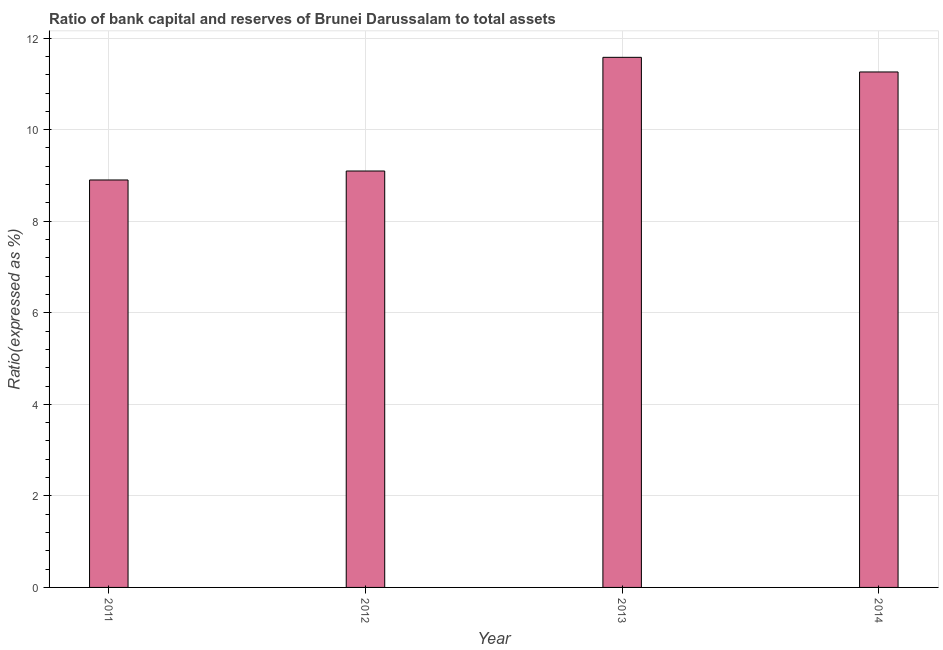Does the graph contain grids?
Ensure brevity in your answer.  Yes. What is the title of the graph?
Provide a short and direct response. Ratio of bank capital and reserves of Brunei Darussalam to total assets. What is the label or title of the X-axis?
Your answer should be very brief. Year. What is the label or title of the Y-axis?
Keep it short and to the point. Ratio(expressed as %). What is the bank capital to assets ratio in 2014?
Your answer should be compact. 11.26. Across all years, what is the maximum bank capital to assets ratio?
Make the answer very short. 11.58. Across all years, what is the minimum bank capital to assets ratio?
Make the answer very short. 8.9. In which year was the bank capital to assets ratio maximum?
Keep it short and to the point. 2013. In which year was the bank capital to assets ratio minimum?
Ensure brevity in your answer.  2011. What is the sum of the bank capital to assets ratio?
Provide a succinct answer. 40.84. What is the difference between the bank capital to assets ratio in 2011 and 2013?
Your answer should be very brief. -2.68. What is the average bank capital to assets ratio per year?
Make the answer very short. 10.21. What is the median bank capital to assets ratio?
Ensure brevity in your answer.  10.18. What is the ratio of the bank capital to assets ratio in 2011 to that in 2014?
Your response must be concise. 0.79. What is the difference between the highest and the second highest bank capital to assets ratio?
Ensure brevity in your answer.  0.32. Is the sum of the bank capital to assets ratio in 2012 and 2013 greater than the maximum bank capital to assets ratio across all years?
Provide a short and direct response. Yes. What is the difference between the highest and the lowest bank capital to assets ratio?
Your answer should be very brief. 2.68. In how many years, is the bank capital to assets ratio greater than the average bank capital to assets ratio taken over all years?
Make the answer very short. 2. How many bars are there?
Offer a very short reply. 4. How many years are there in the graph?
Give a very brief answer. 4. Are the values on the major ticks of Y-axis written in scientific E-notation?
Provide a short and direct response. No. What is the Ratio(expressed as %) in 2011?
Give a very brief answer. 8.9. What is the Ratio(expressed as %) in 2012?
Ensure brevity in your answer.  9.1. What is the Ratio(expressed as %) of 2013?
Your answer should be compact. 11.58. What is the Ratio(expressed as %) in 2014?
Your answer should be compact. 11.26. What is the difference between the Ratio(expressed as %) in 2011 and 2012?
Ensure brevity in your answer.  -0.2. What is the difference between the Ratio(expressed as %) in 2011 and 2013?
Provide a succinct answer. -2.68. What is the difference between the Ratio(expressed as %) in 2011 and 2014?
Make the answer very short. -2.36. What is the difference between the Ratio(expressed as %) in 2012 and 2013?
Ensure brevity in your answer.  -2.48. What is the difference between the Ratio(expressed as %) in 2012 and 2014?
Your response must be concise. -2.16. What is the difference between the Ratio(expressed as %) in 2013 and 2014?
Offer a very short reply. 0.32. What is the ratio of the Ratio(expressed as %) in 2011 to that in 2012?
Give a very brief answer. 0.98. What is the ratio of the Ratio(expressed as %) in 2011 to that in 2013?
Your answer should be very brief. 0.77. What is the ratio of the Ratio(expressed as %) in 2011 to that in 2014?
Your response must be concise. 0.79. What is the ratio of the Ratio(expressed as %) in 2012 to that in 2013?
Your answer should be very brief. 0.79. What is the ratio of the Ratio(expressed as %) in 2012 to that in 2014?
Give a very brief answer. 0.81. What is the ratio of the Ratio(expressed as %) in 2013 to that in 2014?
Your answer should be compact. 1.03. 